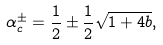Convert formula to latex. <formula><loc_0><loc_0><loc_500><loc_500>\alpha _ { c } ^ { \pm } = \frac { 1 } { 2 } \pm \frac { 1 } { 2 } \sqrt { 1 + 4 b } ,</formula> 